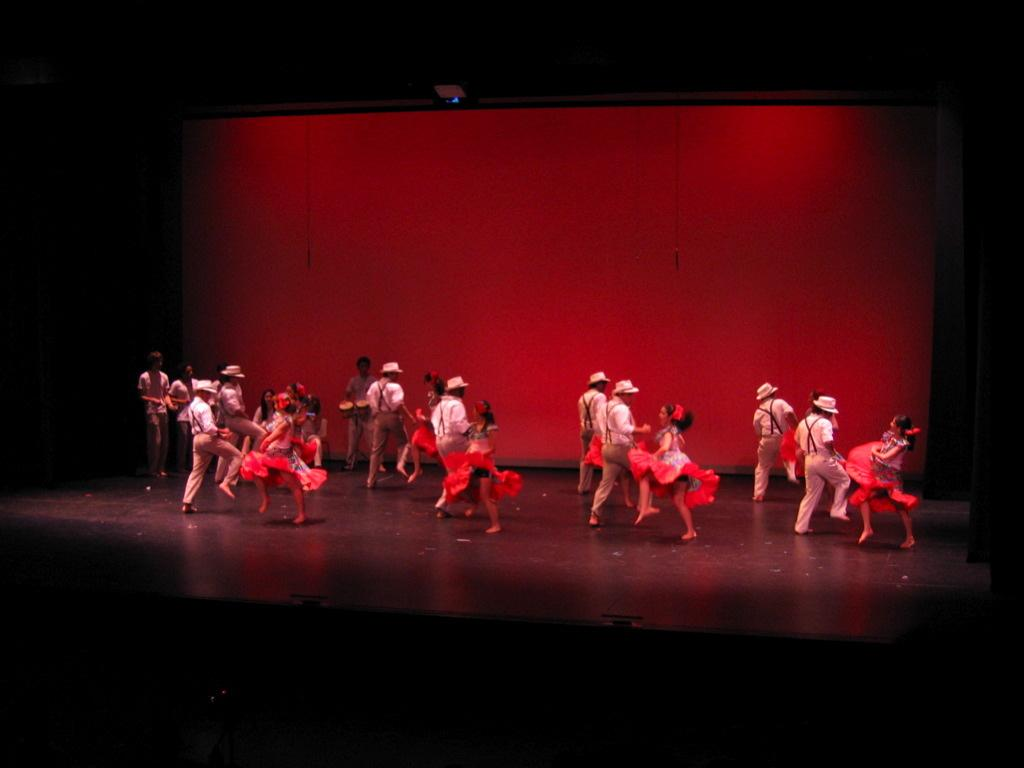What are the people in the image doing? There is a group of people dancing on the stage. Are there any musicians among the dancers? Yes, some people are holding musical instruments. What can be observed about the background of the image? The background is red and dark. What type of loss did the uncle experience before the event in the image? There is no information about an uncle or any loss in the image or the provided facts. 